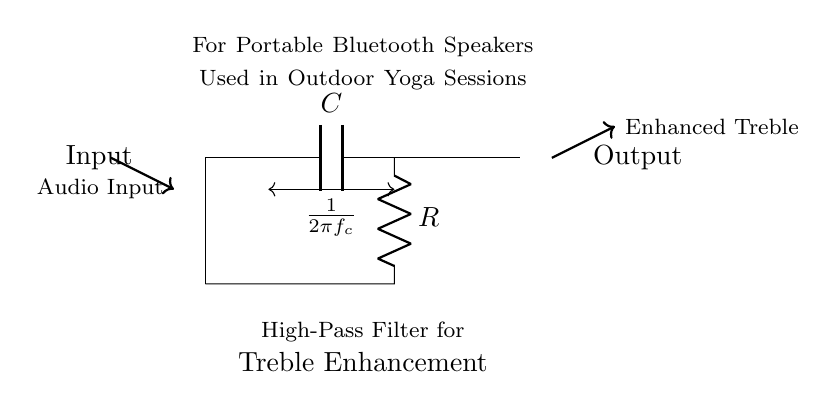What is the type of filter shown in the circuit? The circuit is identified as a high-pass filter, which allows high-frequency signals to pass while attenuating low-frequency signals. This is indicated by the component arrangement, where a capacitor is placed before a resistor.
Answer: high-pass filter What components are used in this circuit? The circuit consists of two primary components: a capacitor (labeled C) and a resistor (labeled R). These are essential for forming the filter characteristics of the circuit.
Answer: capacitor and resistor What is the direction of current flow in this circuit? The current flows from the input towards the output, moving through the capacitor and then the resistor. This direction can be inferred from the flow indicated in the diagram.
Answer: from input to output What does the notation "1/(2πfc)" represent in this circuit? The notation "1/(2πfc)" indicates the time constant or the cutoff frequency of the high-pass filter. It quantitatively describes the relationship between frequency and the phase shift in the circuit.
Answer: cutoff frequency Why is this filter used in portable Bluetooth speakers for outdoor yoga sessions? This filter enhances treble frequencies, which make vocal clarity and high-frequency sounds more perceivable. This is especially beneficial in outdoor environments where such frequencies might otherwise be lost amidst background noise.
Answer: to enhance treble What is the output of this circuit described as? The output from the circuit is described as "Enhanced Treble," which signifies that the high frequencies amplified by the filter will be delivered to the speaker system. This highlights the filter's function in audio processing.
Answer: Enhanced Treble Where is the audio input connected in relation to the components? The audio input is connected directly to the capacitor, which is placed at the beginning of the circuit. This placement allows the low frequencies to be blocked while allowing higher frequencies to pass through to the output.
Answer: to the capacitor 